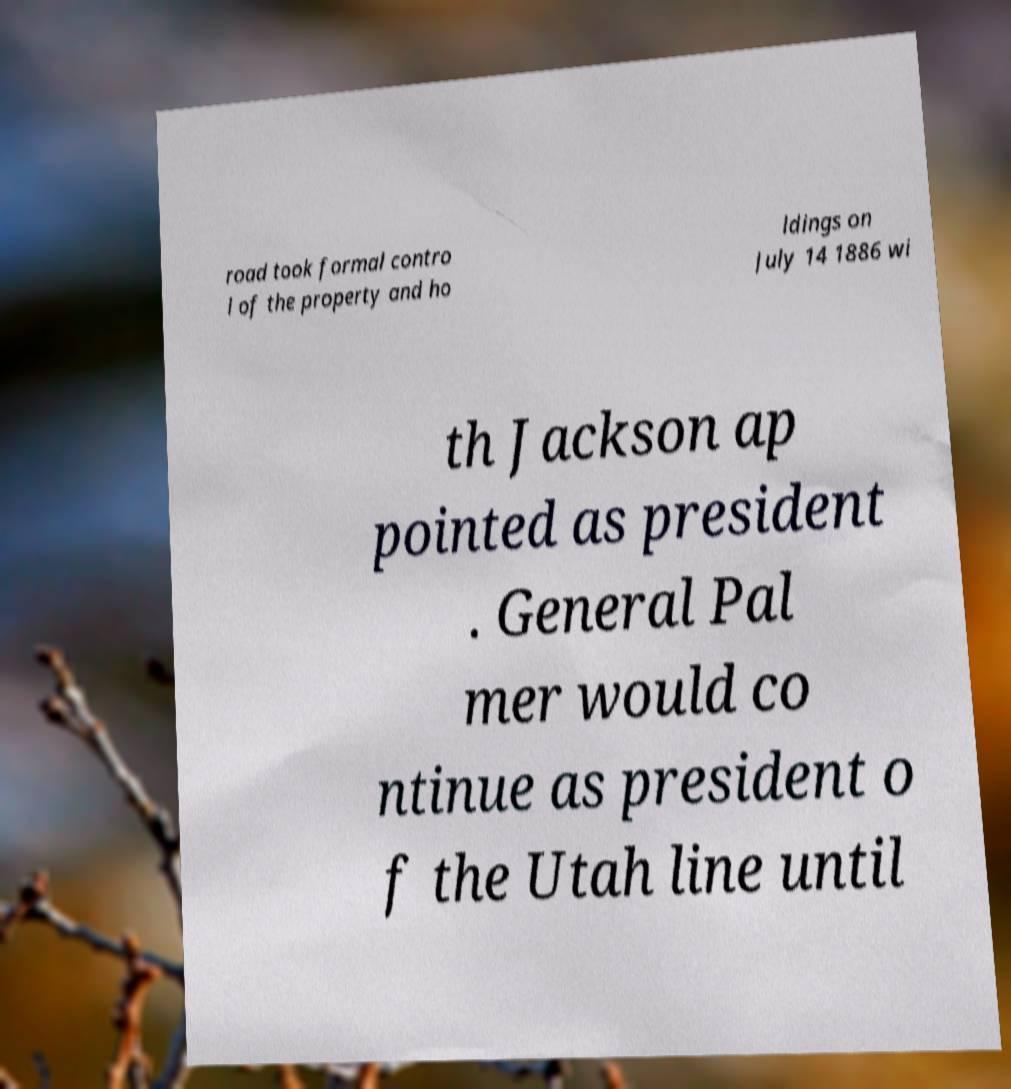There's text embedded in this image that I need extracted. Can you transcribe it verbatim? road took formal contro l of the property and ho ldings on July 14 1886 wi th Jackson ap pointed as president . General Pal mer would co ntinue as president o f the Utah line until 